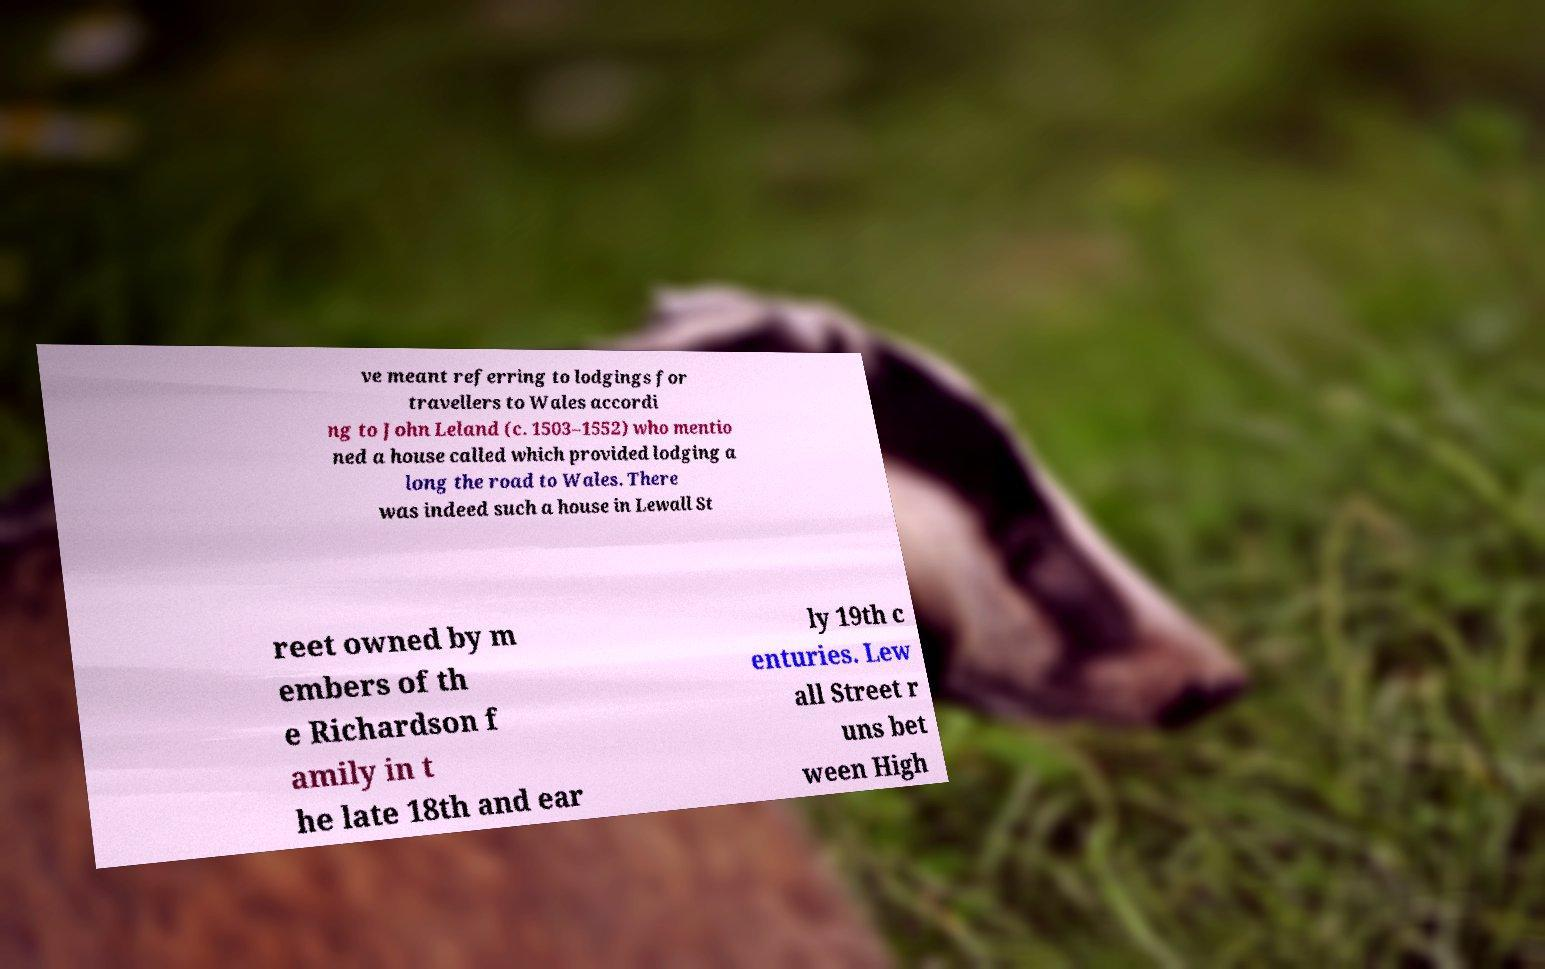Please identify and transcribe the text found in this image. ve meant referring to lodgings for travellers to Wales accordi ng to John Leland (c. 1503–1552) who mentio ned a house called which provided lodging a long the road to Wales. There was indeed such a house in Lewall St reet owned by m embers of th e Richardson f amily in t he late 18th and ear ly 19th c enturies. Lew all Street r uns bet ween High 